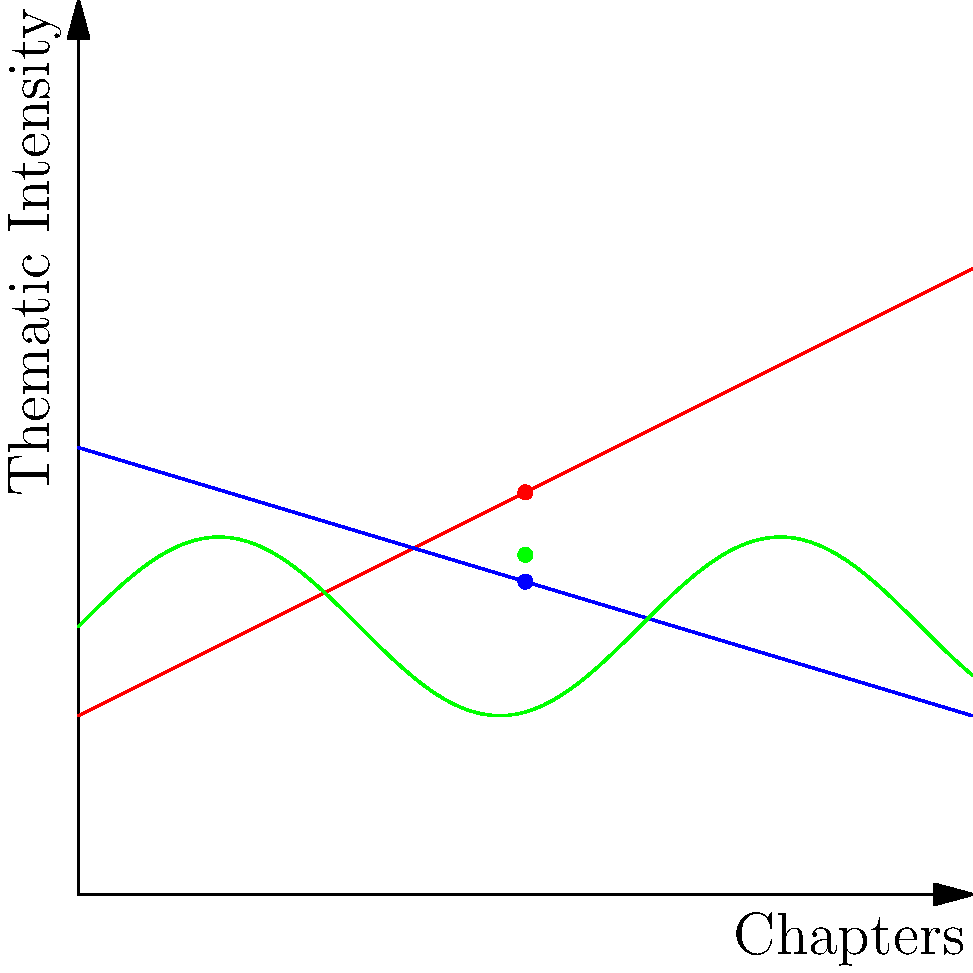In the vector analysis of thematic progression across chapters in a novel, three themes (A, B, and C) are represented by the red, blue, and green lines respectively. At chapter 5, the thematic intensities form a vector $\vec{v} = (4.5, 3.5, 3.8)$. If we consider this vector as a resultant of two component vectors $\vec{a}$ and $\vec{b}$, where $\vec{a} = (2, 1, 2)$, what is $\vec{b}$? To find $\vec{b}$, we need to follow these steps:

1) We know that $\vec{v} = \vec{a} + \vec{b}$, where $\vec{v} = (4.5, 3.5, 3.8)$ and $\vec{a} = (2, 1, 2)$.

2) To find $\vec{b}$, we need to subtract $\vec{a}$ from $\vec{v}$:

   $\vec{b} = \vec{v} - \vec{a}$

3) Let's perform this subtraction component-wise:
   
   $b_x = v_x - a_x = 4.5 - 2 = 2.5$
   $b_y = v_y - a_y = 3.5 - 1 = 2.5$
   $b_z = v_z - a_z = 3.8 - 2 = 1.8$

4) Therefore, $\vec{b} = (2.5, 2.5, 1.8)$

This vector $\vec{b}$ represents the additional thematic intensity beyond the base vector $\vec{a}$, showing how the themes have developed from their initial states.
Answer: $(2.5, 2.5, 1.8)$ 